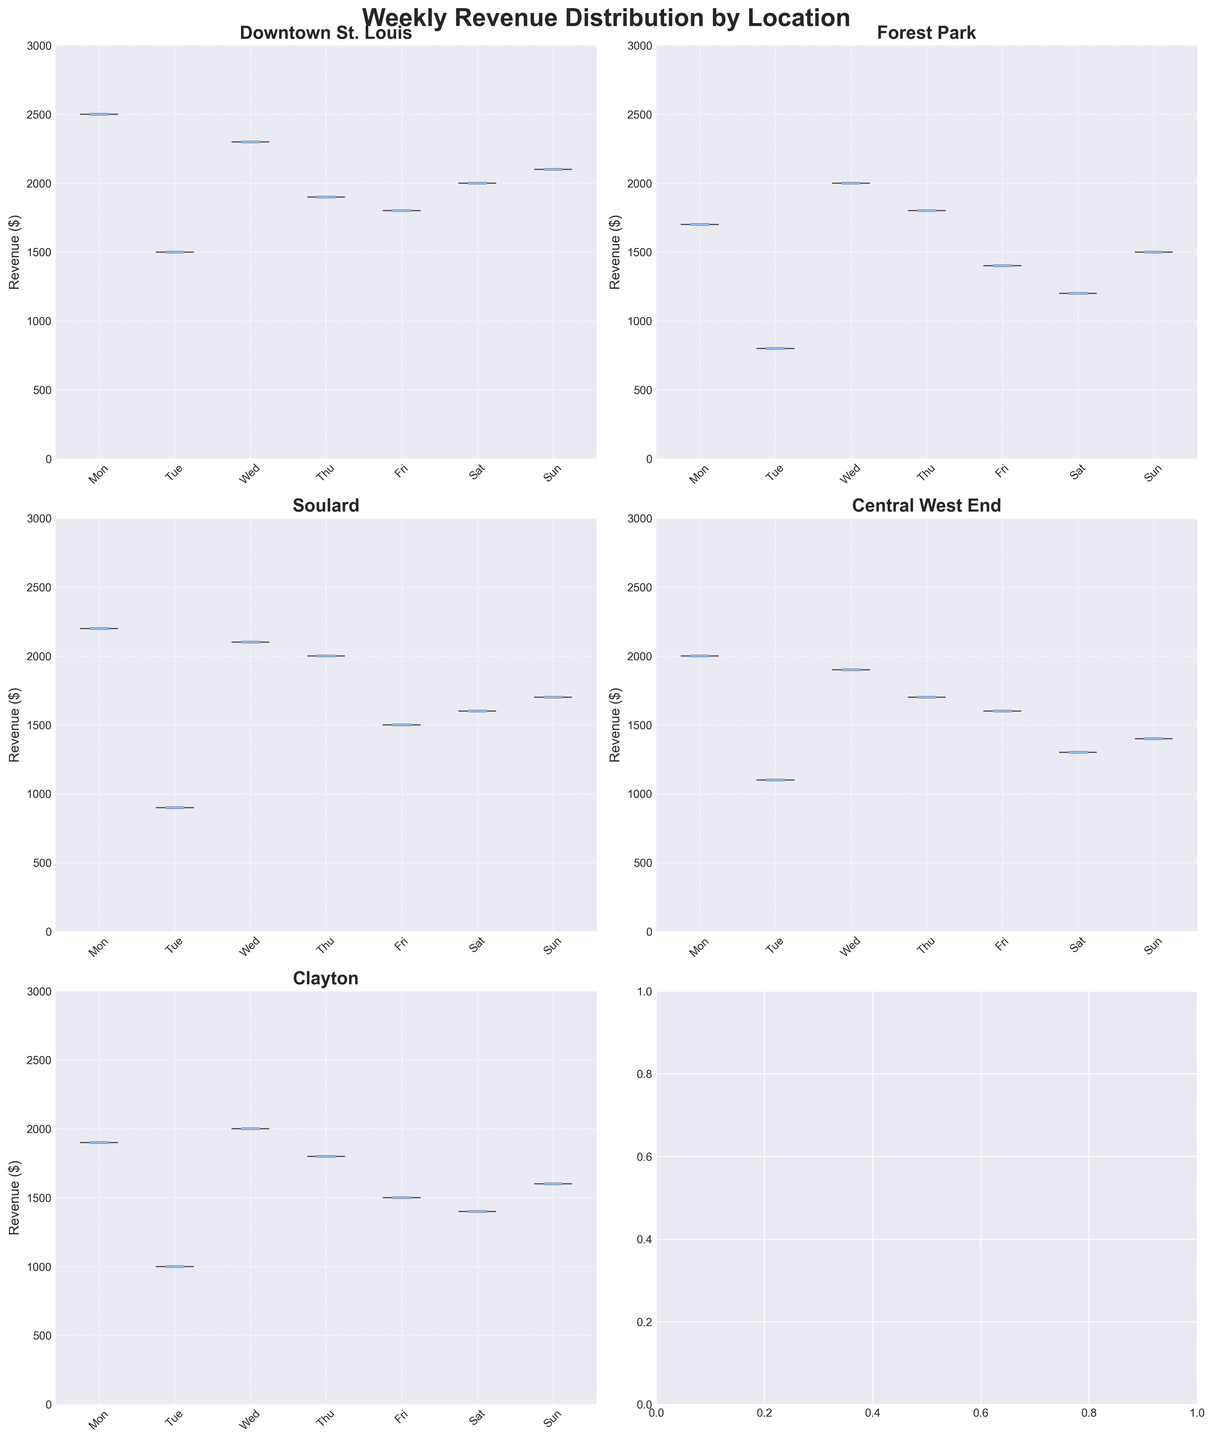What is the title of the plot? The title is usually placed at the top center of the plot. In this case, it reads "Weekly Revenue Distribution by Location" which conveys the overall subject of the chart.
Answer: Weekly Revenue Distribution by Location How many different food truck locations are included in the plot? By counting the different subplots, we can see that there are 5 distinct locations included in the plot: Downtown St. Louis, Forest Park, Soulard, Central West End, and Clayton.
Answer: 5 Which food truck location has the highest median revenue on Friday? By observing the plots for each location on Friday, we compare the median points. The Downtown St. Louis plot shows the highest position of the median line on Friday.
Answer: Downtown St. Louis Which day of the week shows the highest mean revenue for Forest Park? Observing the Forest Park subplot, we can determine which day has the highest mean line. The revenue peaks on Saturday.
Answer: Saturday What is the range of the revenue distribution for Soulard on Saturday? The range can be found by looking at the lower and upper extremes of the violin plot for Soulard on Saturday. The values range from around 1500 to 2100 dollars.
Answer: 600 dollars For Central West End, which weekday shows the smallest interquartile range (IQR) in revenue? The IQR is the range between the 25th and 75th percentiles. Observing the plot for Central West End, the narrowest section of the violin plot within the boxplot part indicates the smallest IQR, which occurs on Tuesday.
Answer: Tuesday How does the mean revenue on Monday for Clayton compare to that on Saturday? Comparing the height of the mean dots on the Clayton subplot for Monday and Saturday, it's evident that the mean revenue is higher on Saturday than on Monday.
Answer: Higher on Saturday Which location has the most uniform revenue distribution across the weekdays, judging by the violin plot shapes? Uniform distribution means the widths of the violins are relatively consistent. Observing all subplots, Forest Park shows the most uniform distribution with similar shapes across the days.
Answer: Forest Park What is the maximum observed revenue for Downtown St. Louis? Observing the highest point in the Downtown St. Louis plot, the maximum revenue value across all days appears around 2500 dollars on Friday.
Answer: 2500 dollars 